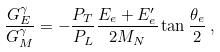<formula> <loc_0><loc_0><loc_500><loc_500>\frac { G _ { E } ^ { \gamma } } { G _ { M } ^ { \gamma } } = - \frac { P _ { T } } { P _ { L } } \frac { E _ { e } + E _ { e } ^ { \prime } } { 2 M _ { N } } \tan \frac { \theta _ { e } } { 2 } \, ,</formula> 